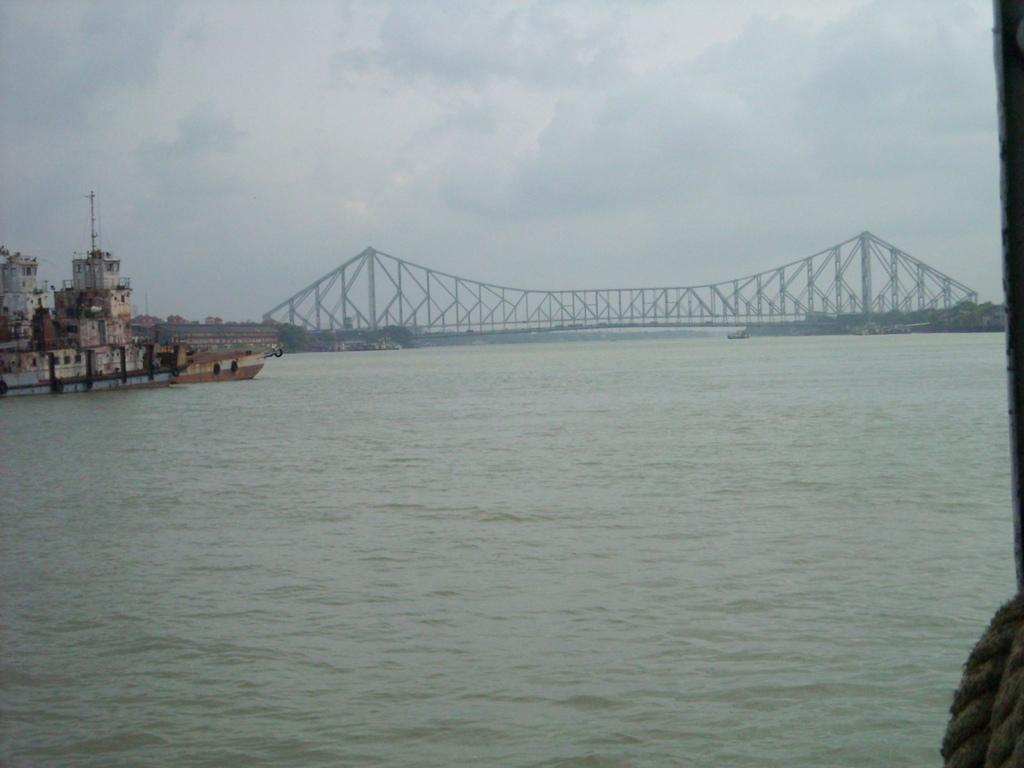What type of body of water is present in the image? There is a sea in the image. What structure can be seen crossing the sea? There is a bridge in the image. What type of vehicle is in the water? There is a ship in the water. What is the condition of the sky in the image? The sky is cloudy in the image. What type of structures can be seen in the image? There are buildings in the image. Can you tell me how many trains are exchanging crackers on the bridge in the image? There are no trains or crackers present in the image. The image features a sea, a bridge, a ship, a rope, a cloudy sky, and buildings. 